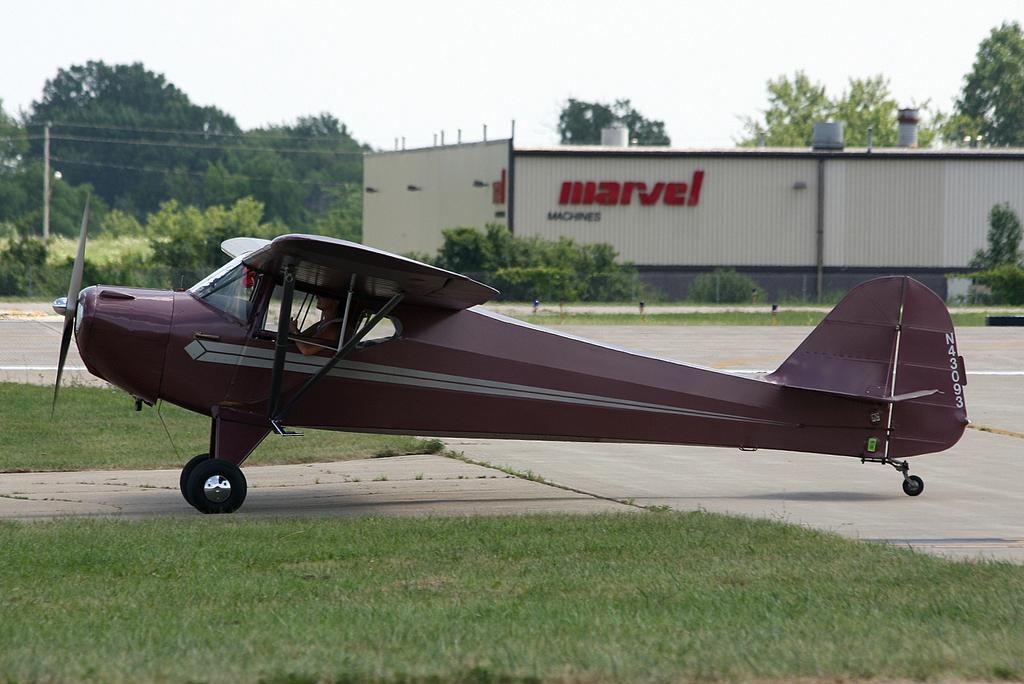Could you give a brief overview of what you see in this image? In the foreground I can see a helicopter on the ground and grass. In the background I can see a godown, poles, wires and trees. On the top I can see the sky. This image is taken during a day. 